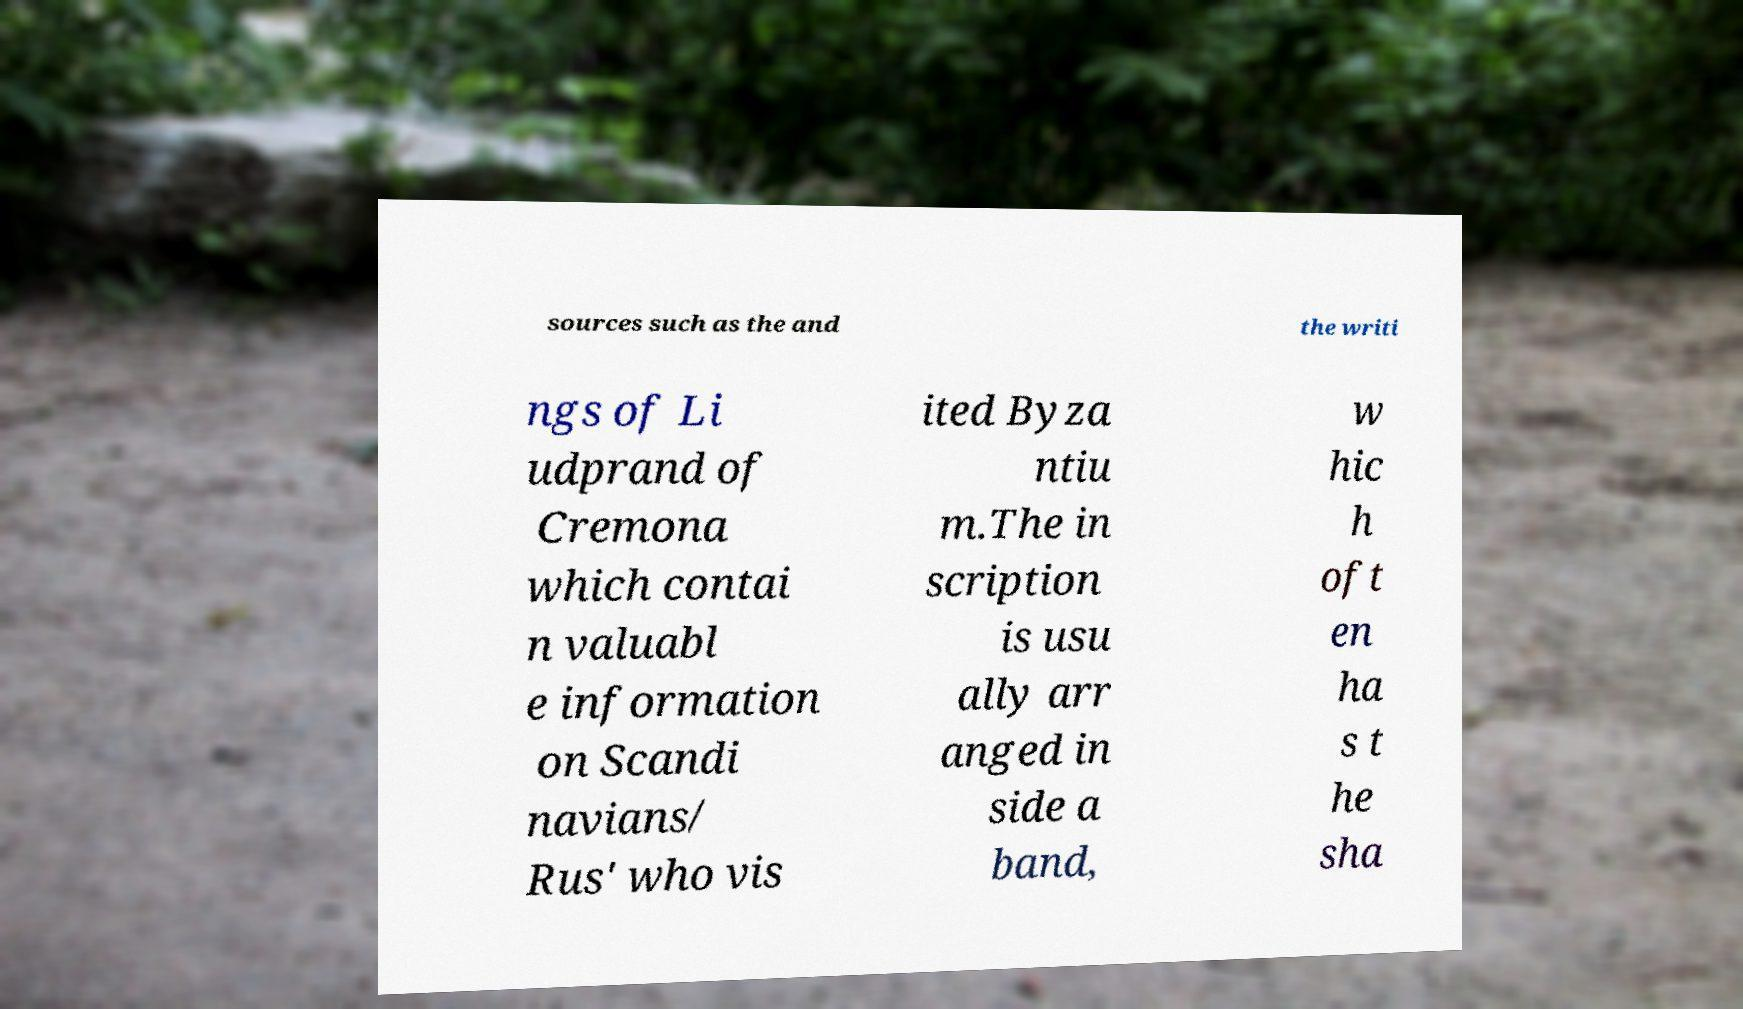There's text embedded in this image that I need extracted. Can you transcribe it verbatim? sources such as the and the writi ngs of Li udprand of Cremona which contai n valuabl e information on Scandi navians/ Rus' who vis ited Byza ntiu m.The in scription is usu ally arr anged in side a band, w hic h oft en ha s t he sha 